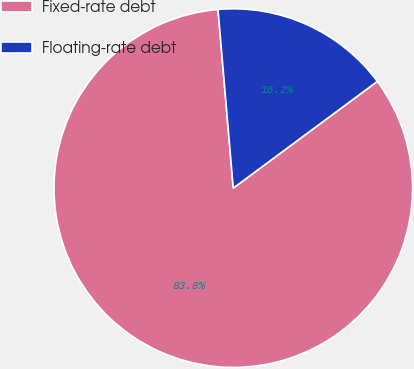Convert chart to OTSL. <chart><loc_0><loc_0><loc_500><loc_500><pie_chart><fcel>Fixed-rate debt<fcel>Floating-rate debt<nl><fcel>83.79%<fcel>16.21%<nl></chart> 